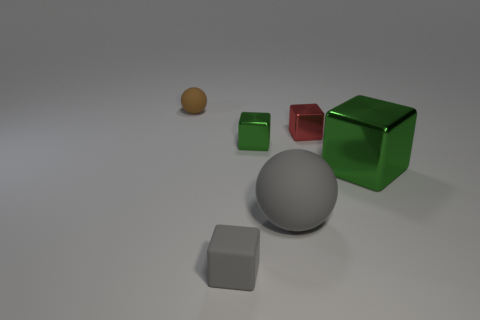There is a sphere that is the same color as the rubber block; what is it made of?
Your answer should be very brief. Rubber. What is the size of the thing that is the same color as the tiny matte block?
Your answer should be very brief. Large. There is a ball in front of the brown rubber ball; does it have the same size as the big shiny thing?
Your answer should be very brief. Yes. How many objects are on the right side of the tiny rubber block and behind the gray sphere?
Your answer should be very brief. 3. What is the size of the matte ball behind the green shiny object left of the large shiny object?
Keep it short and to the point. Small. Are there fewer small red shiny objects behind the tiny green block than tiny brown rubber spheres to the right of the small brown matte thing?
Keep it short and to the point. No. There is a tiny rubber object in front of the small brown thing; is it the same color as the large object on the right side of the gray sphere?
Give a very brief answer. No. There is a tiny thing that is left of the small green shiny object and in front of the brown rubber object; what is its material?
Provide a succinct answer. Rubber. Is there a rubber ball?
Ensure brevity in your answer.  Yes. There is a tiny brown object that is made of the same material as the large gray object; what shape is it?
Offer a terse response. Sphere. 